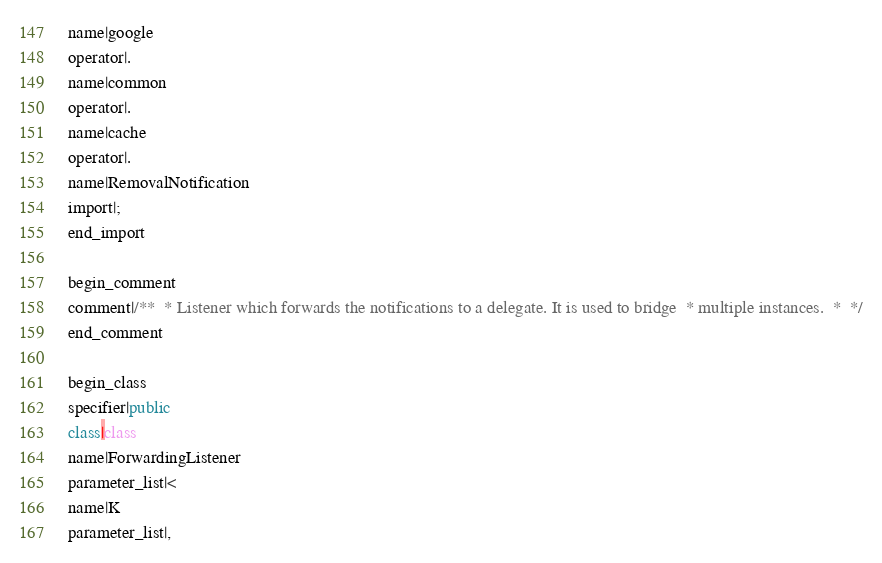Convert code to text. <code><loc_0><loc_0><loc_500><loc_500><_Java_>name|google
operator|.
name|common
operator|.
name|cache
operator|.
name|RemovalNotification
import|;
end_import

begin_comment
comment|/**  * Listener which forwards the notifications to a delegate. It is used to bridge  * multiple instances.  *  */
end_comment

begin_class
specifier|public
class|class
name|ForwardingListener
parameter_list|<
name|K
parameter_list|,</code> 